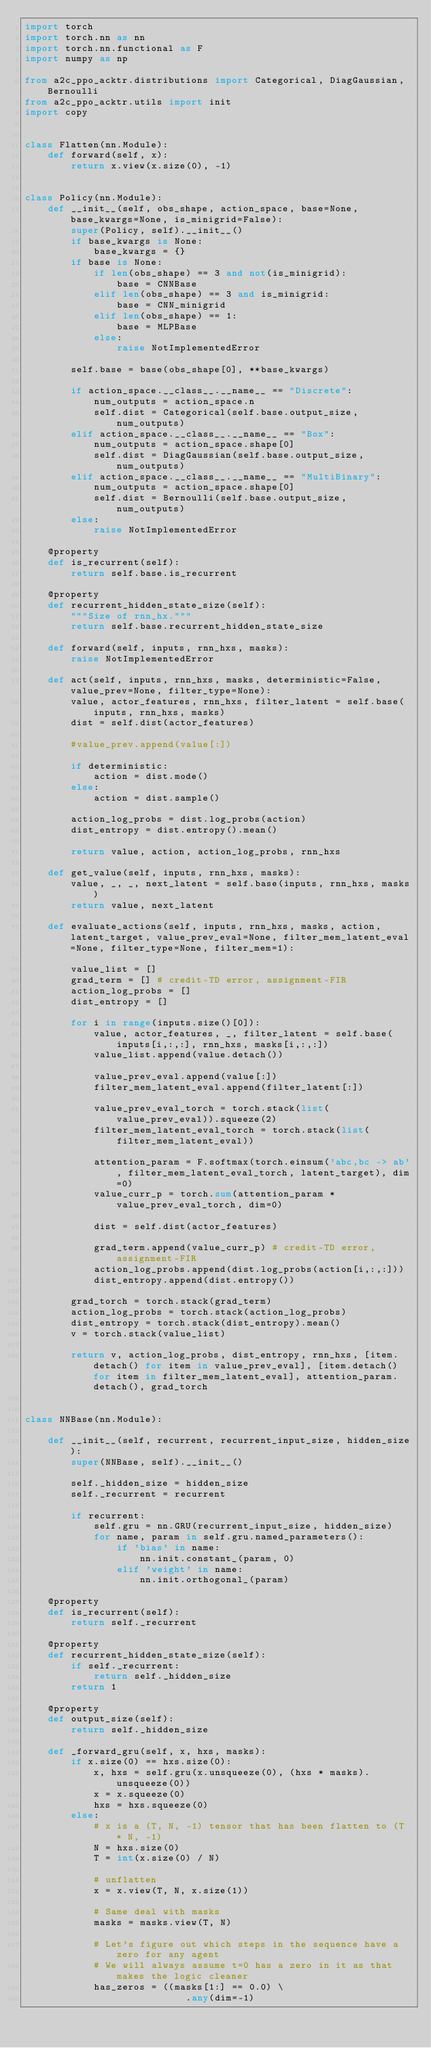<code> <loc_0><loc_0><loc_500><loc_500><_Python_>import torch
import torch.nn as nn
import torch.nn.functional as F
import numpy as np

from a2c_ppo_acktr.distributions import Categorical, DiagGaussian, Bernoulli
from a2c_ppo_acktr.utils import init
import copy


class Flatten(nn.Module):
    def forward(self, x):
        return x.view(x.size(0), -1)


class Policy(nn.Module):
    def __init__(self, obs_shape, action_space, base=None, base_kwargs=None, is_minigrid=False):
        super(Policy, self).__init__()
        if base_kwargs is None:
            base_kwargs = {}
        if base is None:
            if len(obs_shape) == 3 and not(is_minigrid):
                base = CNNBase
            elif len(obs_shape) == 3 and is_minigrid:
                base = CNN_minigrid
            elif len(obs_shape) == 1:
                base = MLPBase
            else:
                raise NotImplementedError

        self.base = base(obs_shape[0], **base_kwargs)

        if action_space.__class__.__name__ == "Discrete":
            num_outputs = action_space.n
            self.dist = Categorical(self.base.output_size, num_outputs)
        elif action_space.__class__.__name__ == "Box":
            num_outputs = action_space.shape[0]
            self.dist = DiagGaussian(self.base.output_size, num_outputs)
        elif action_space.__class__.__name__ == "MultiBinary":
            num_outputs = action_space.shape[0]
            self.dist = Bernoulli(self.base.output_size, num_outputs)
        else:
            raise NotImplementedError

    @property
    def is_recurrent(self):
        return self.base.is_recurrent

    @property
    def recurrent_hidden_state_size(self):
        """Size of rnn_hx."""
        return self.base.recurrent_hidden_state_size

    def forward(self, inputs, rnn_hxs, masks):
        raise NotImplementedError

    def act(self, inputs, rnn_hxs, masks, deterministic=False, value_prev=None, filter_type=None):
        value, actor_features, rnn_hxs, filter_latent = self.base(inputs, rnn_hxs, masks)
        dist = self.dist(actor_features)

        #value_prev.append(value[:])

        if deterministic:
            action = dist.mode()
        else:
            action = dist.sample()

        action_log_probs = dist.log_probs(action)
        dist_entropy = dist.entropy().mean()

        return value, action, action_log_probs, rnn_hxs

    def get_value(self, inputs, rnn_hxs, masks):
        value, _, _, next_latent = self.base(inputs, rnn_hxs, masks)
        return value, next_latent

    def evaluate_actions(self, inputs, rnn_hxs, masks, action, latent_target, value_prev_eval=None, filter_mem_latent_eval=None, filter_type=None, filter_mem=1):

        value_list = []
        grad_term = [] # credit-TD error, assignment-FIR
        action_log_probs = []
        dist_entropy = []

        for i in range(inputs.size()[0]):
            value, actor_features, _, filter_latent = self.base(inputs[i,:,:], rnn_hxs, masks[i,:,:])
            value_list.append(value.detach())

            value_prev_eval.append(value[:])
            filter_mem_latent_eval.append(filter_latent[:])

            value_prev_eval_torch = torch.stack(list(value_prev_eval)).squeeze(2)
            filter_mem_latent_eval_torch = torch.stack(list(filter_mem_latent_eval))
   
            attention_param = F.softmax(torch.einsum('abc,bc -> ab', filter_mem_latent_eval_torch, latent_target), dim=0)
            value_curr_p = torch.sum(attention_param * value_prev_eval_torch, dim=0)

            dist = self.dist(actor_features)

            grad_term.append(value_curr_p) # credit-TD error, assignment-FIR
            action_log_probs.append(dist.log_probs(action[i,:,:]))
            dist_entropy.append(dist.entropy())

        grad_torch = torch.stack(grad_term)
        action_log_probs = torch.stack(action_log_probs)
        dist_entropy = torch.stack(dist_entropy).mean()
        v = torch.stack(value_list)

        return v, action_log_probs, dist_entropy, rnn_hxs, [item.detach() for item in value_prev_eval], [item.detach() for item in filter_mem_latent_eval], attention_param.detach(), grad_torch


class NNBase(nn.Module):

    def __init__(self, recurrent, recurrent_input_size, hidden_size):
        super(NNBase, self).__init__()

        self._hidden_size = hidden_size
        self._recurrent = recurrent

        if recurrent:
            self.gru = nn.GRU(recurrent_input_size, hidden_size)
            for name, param in self.gru.named_parameters():
                if 'bias' in name:
                    nn.init.constant_(param, 0)
                elif 'weight' in name:
                    nn.init.orthogonal_(param)

    @property
    def is_recurrent(self):
        return self._recurrent

    @property
    def recurrent_hidden_state_size(self):
        if self._recurrent:
            return self._hidden_size
        return 1

    @property
    def output_size(self):
        return self._hidden_size

    def _forward_gru(self, x, hxs, masks):
        if x.size(0) == hxs.size(0):
            x, hxs = self.gru(x.unsqueeze(0), (hxs * masks).unsqueeze(0))
            x = x.squeeze(0)
            hxs = hxs.squeeze(0)
        else:
            # x is a (T, N, -1) tensor that has been flatten to (T * N, -1)
            N = hxs.size(0)
            T = int(x.size(0) / N)

            # unflatten
            x = x.view(T, N, x.size(1))

            # Same deal with masks
            masks = masks.view(T, N)

            # Let's figure out which steps in the sequence have a zero for any agent
            # We will always assume t=0 has a zero in it as that makes the logic cleaner
            has_zeros = ((masks[1:] == 0.0) \
                            .any(dim=-1)</code> 